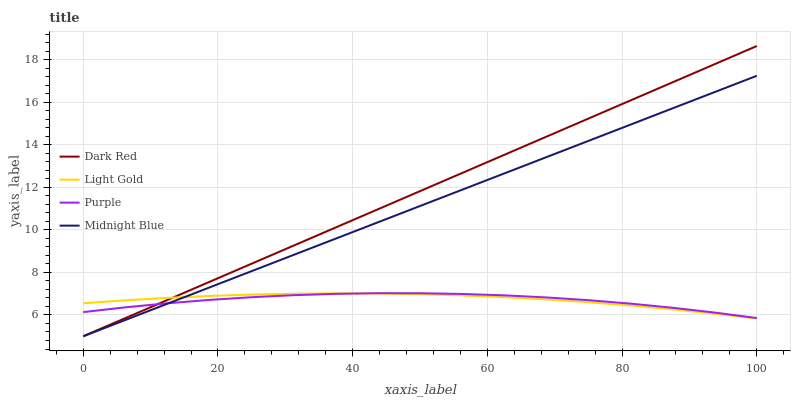Does Purple have the minimum area under the curve?
Answer yes or no. Yes. Does Dark Red have the maximum area under the curve?
Answer yes or no. Yes. Does Light Gold have the minimum area under the curve?
Answer yes or no. No. Does Light Gold have the maximum area under the curve?
Answer yes or no. No. Is Midnight Blue the smoothest?
Answer yes or no. Yes. Is Purple the roughest?
Answer yes or no. Yes. Is Dark Red the smoothest?
Answer yes or no. No. Is Dark Red the roughest?
Answer yes or no. No. Does Dark Red have the lowest value?
Answer yes or no. Yes. Does Light Gold have the lowest value?
Answer yes or no. No. Does Dark Red have the highest value?
Answer yes or no. Yes. Does Light Gold have the highest value?
Answer yes or no. No. Does Light Gold intersect Dark Red?
Answer yes or no. Yes. Is Light Gold less than Dark Red?
Answer yes or no. No. Is Light Gold greater than Dark Red?
Answer yes or no. No. 